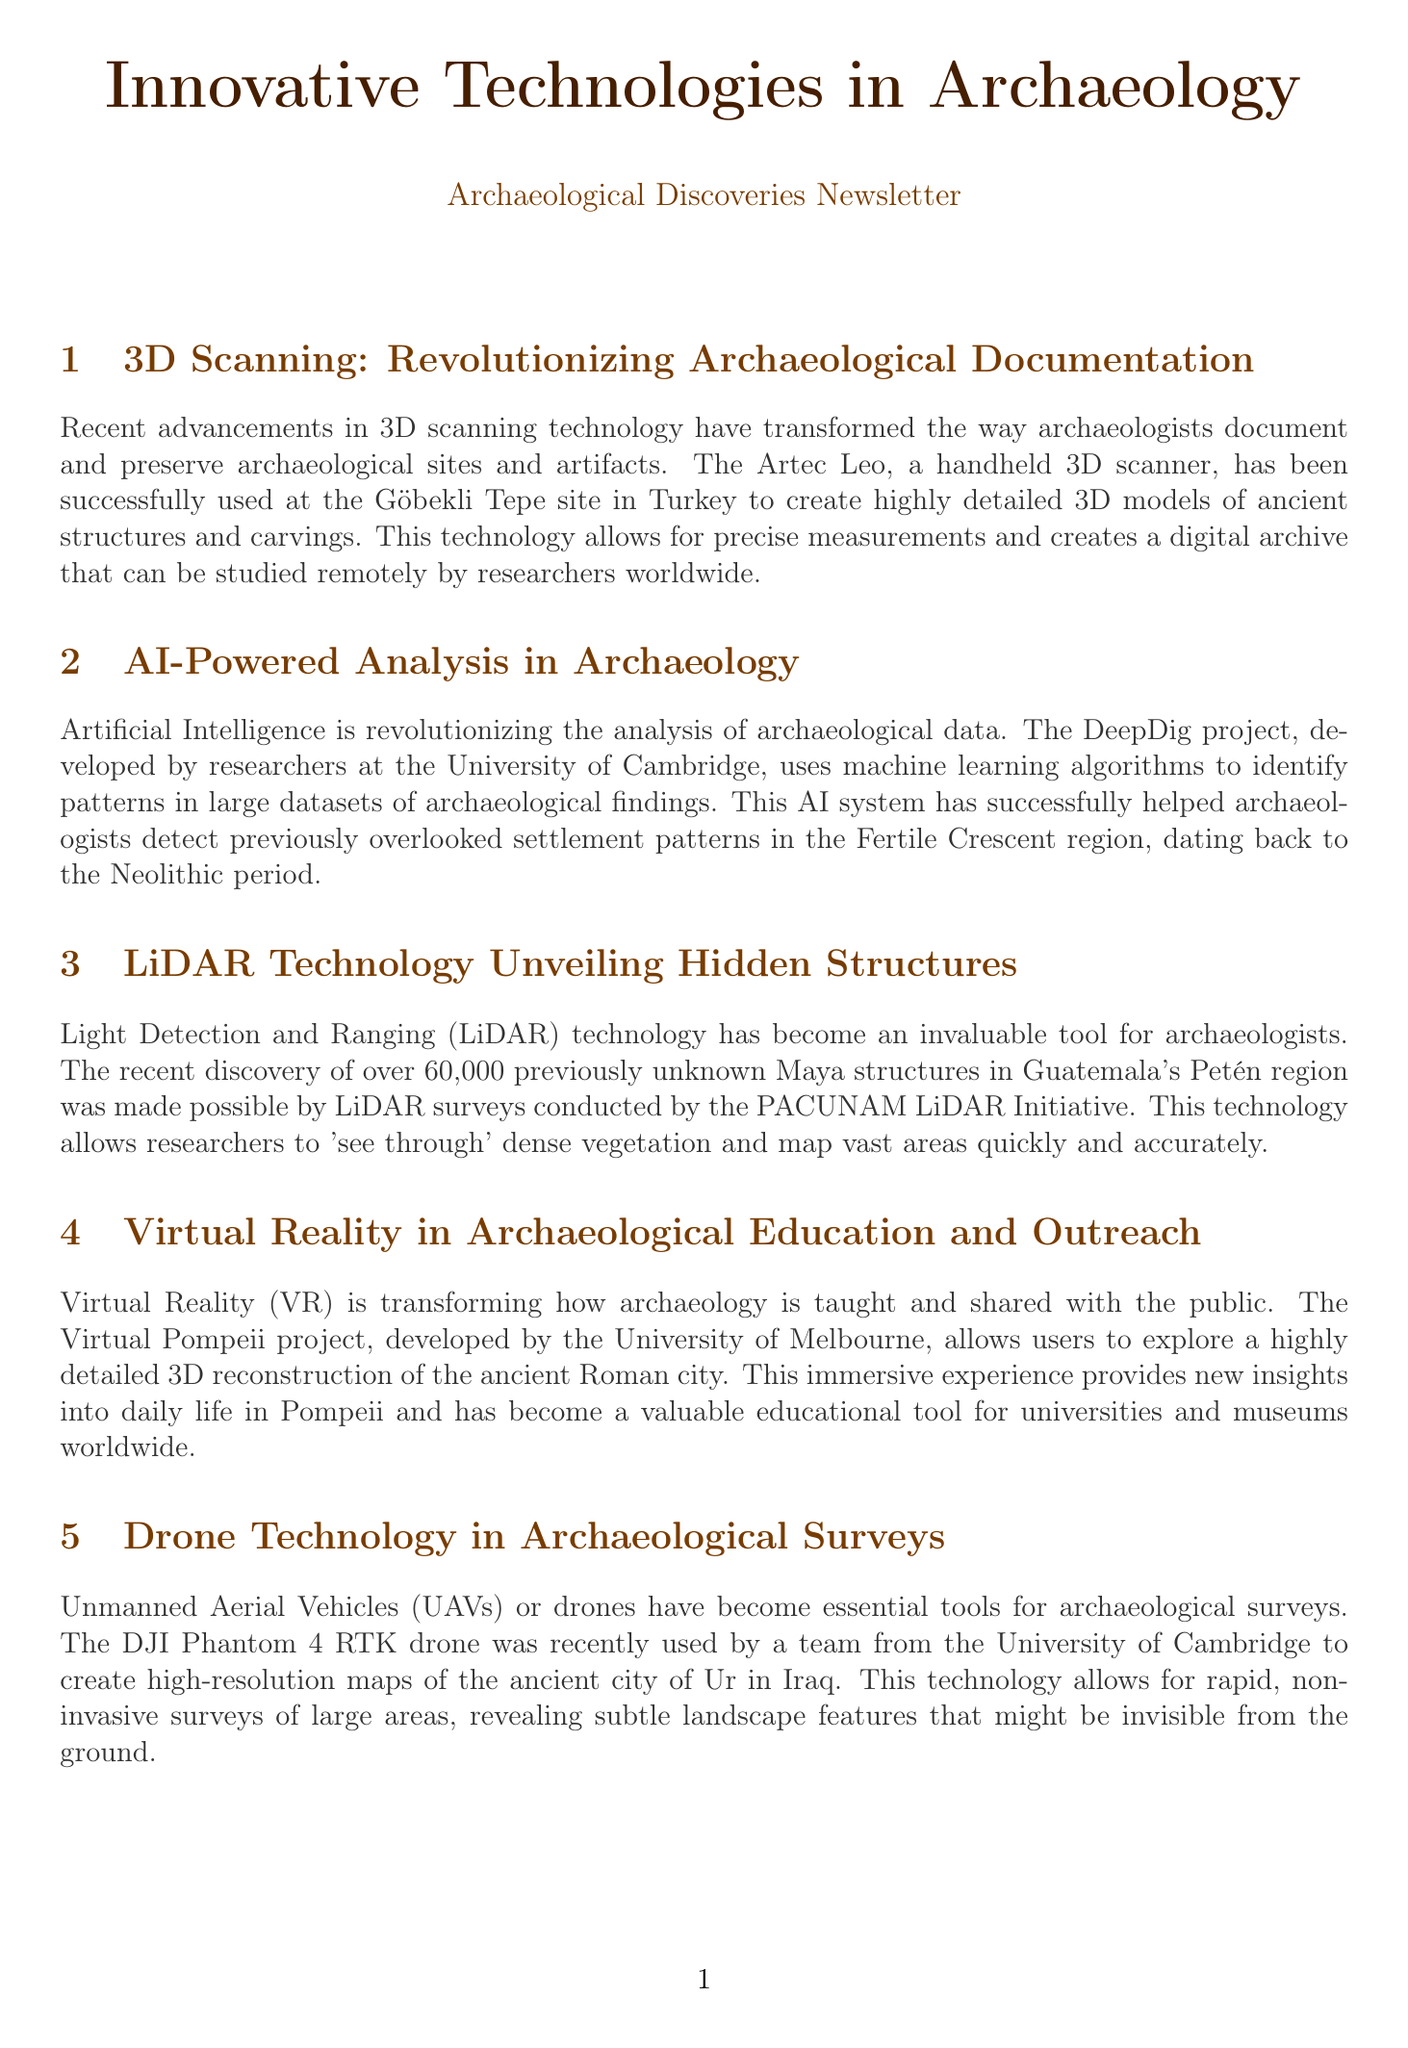What is the name of the handheld 3D scanner mentioned? The document states that the Artec Leo is the handheld 3D scanner used at the Göbekli Tepe site.
Answer: Artec Leo Which university developed the DeepDig project? The document mentions that the DeepDig project was developed by researchers at the University of Cambridge.
Answer: University of Cambridge How many unknown Maya structures were discovered using LiDAR technology? According to the document, over 60,000 previously unknown Maya structures were discovered in Guatemala's Petén region.
Answer: 60,000 What technology allows researchers to 'see through' dense vegetation? The document explains that LiDAR technology enables researchers to see through dense vegetation.
Answer: LiDAR technology What city is the Virtual Pompeii project related to? The document indicates that the Virtual Pompeii project is related to the ancient Roman city of Pompeii.
Answer: Pompeii How does the DJI Phantom 4 RTK drone contribute to archaeological surveys? The document states the drone allows for rapid, non-invasive surveys of large areas, revealing subtle landscape features.
Answer: Rapid, non-invasive surveys What type of experience does the Virtual Pompeii project provide? The document describes the experience as immersive, providing new insights into daily life in Pompeii.
Answer: Immersive experience What main theme connects all the technologies discussed in the newsletter? The document highlights that all technologies aim to enhance archaeological research and documentation.
Answer: Enhancing archaeological research 